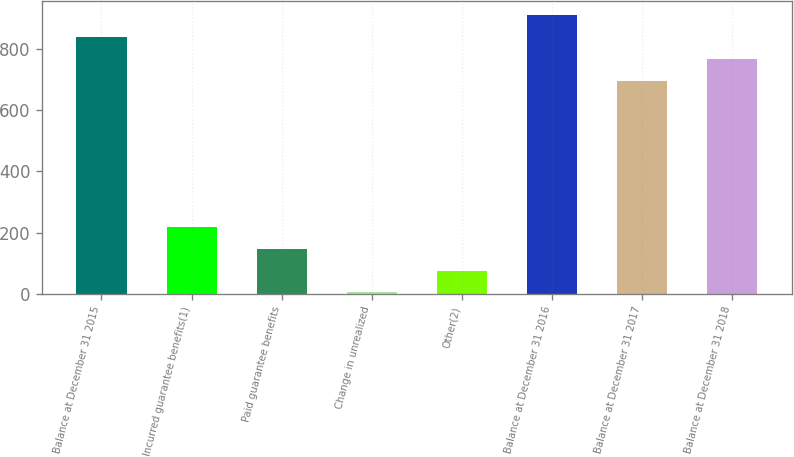Convert chart to OTSL. <chart><loc_0><loc_0><loc_500><loc_500><bar_chart><fcel>Balance at December 31 2015<fcel>Incurred guarantee benefits(1)<fcel>Paid guarantee benefits<fcel>Change in unrealized<fcel>Other(2)<fcel>Balance at December 31 2016<fcel>Balance at December 31 2017<fcel>Balance at December 31 2018<nl><fcel>840.34<fcel>219.34<fcel>147.67<fcel>4.33<fcel>76<fcel>912.01<fcel>697<fcel>768.67<nl></chart> 